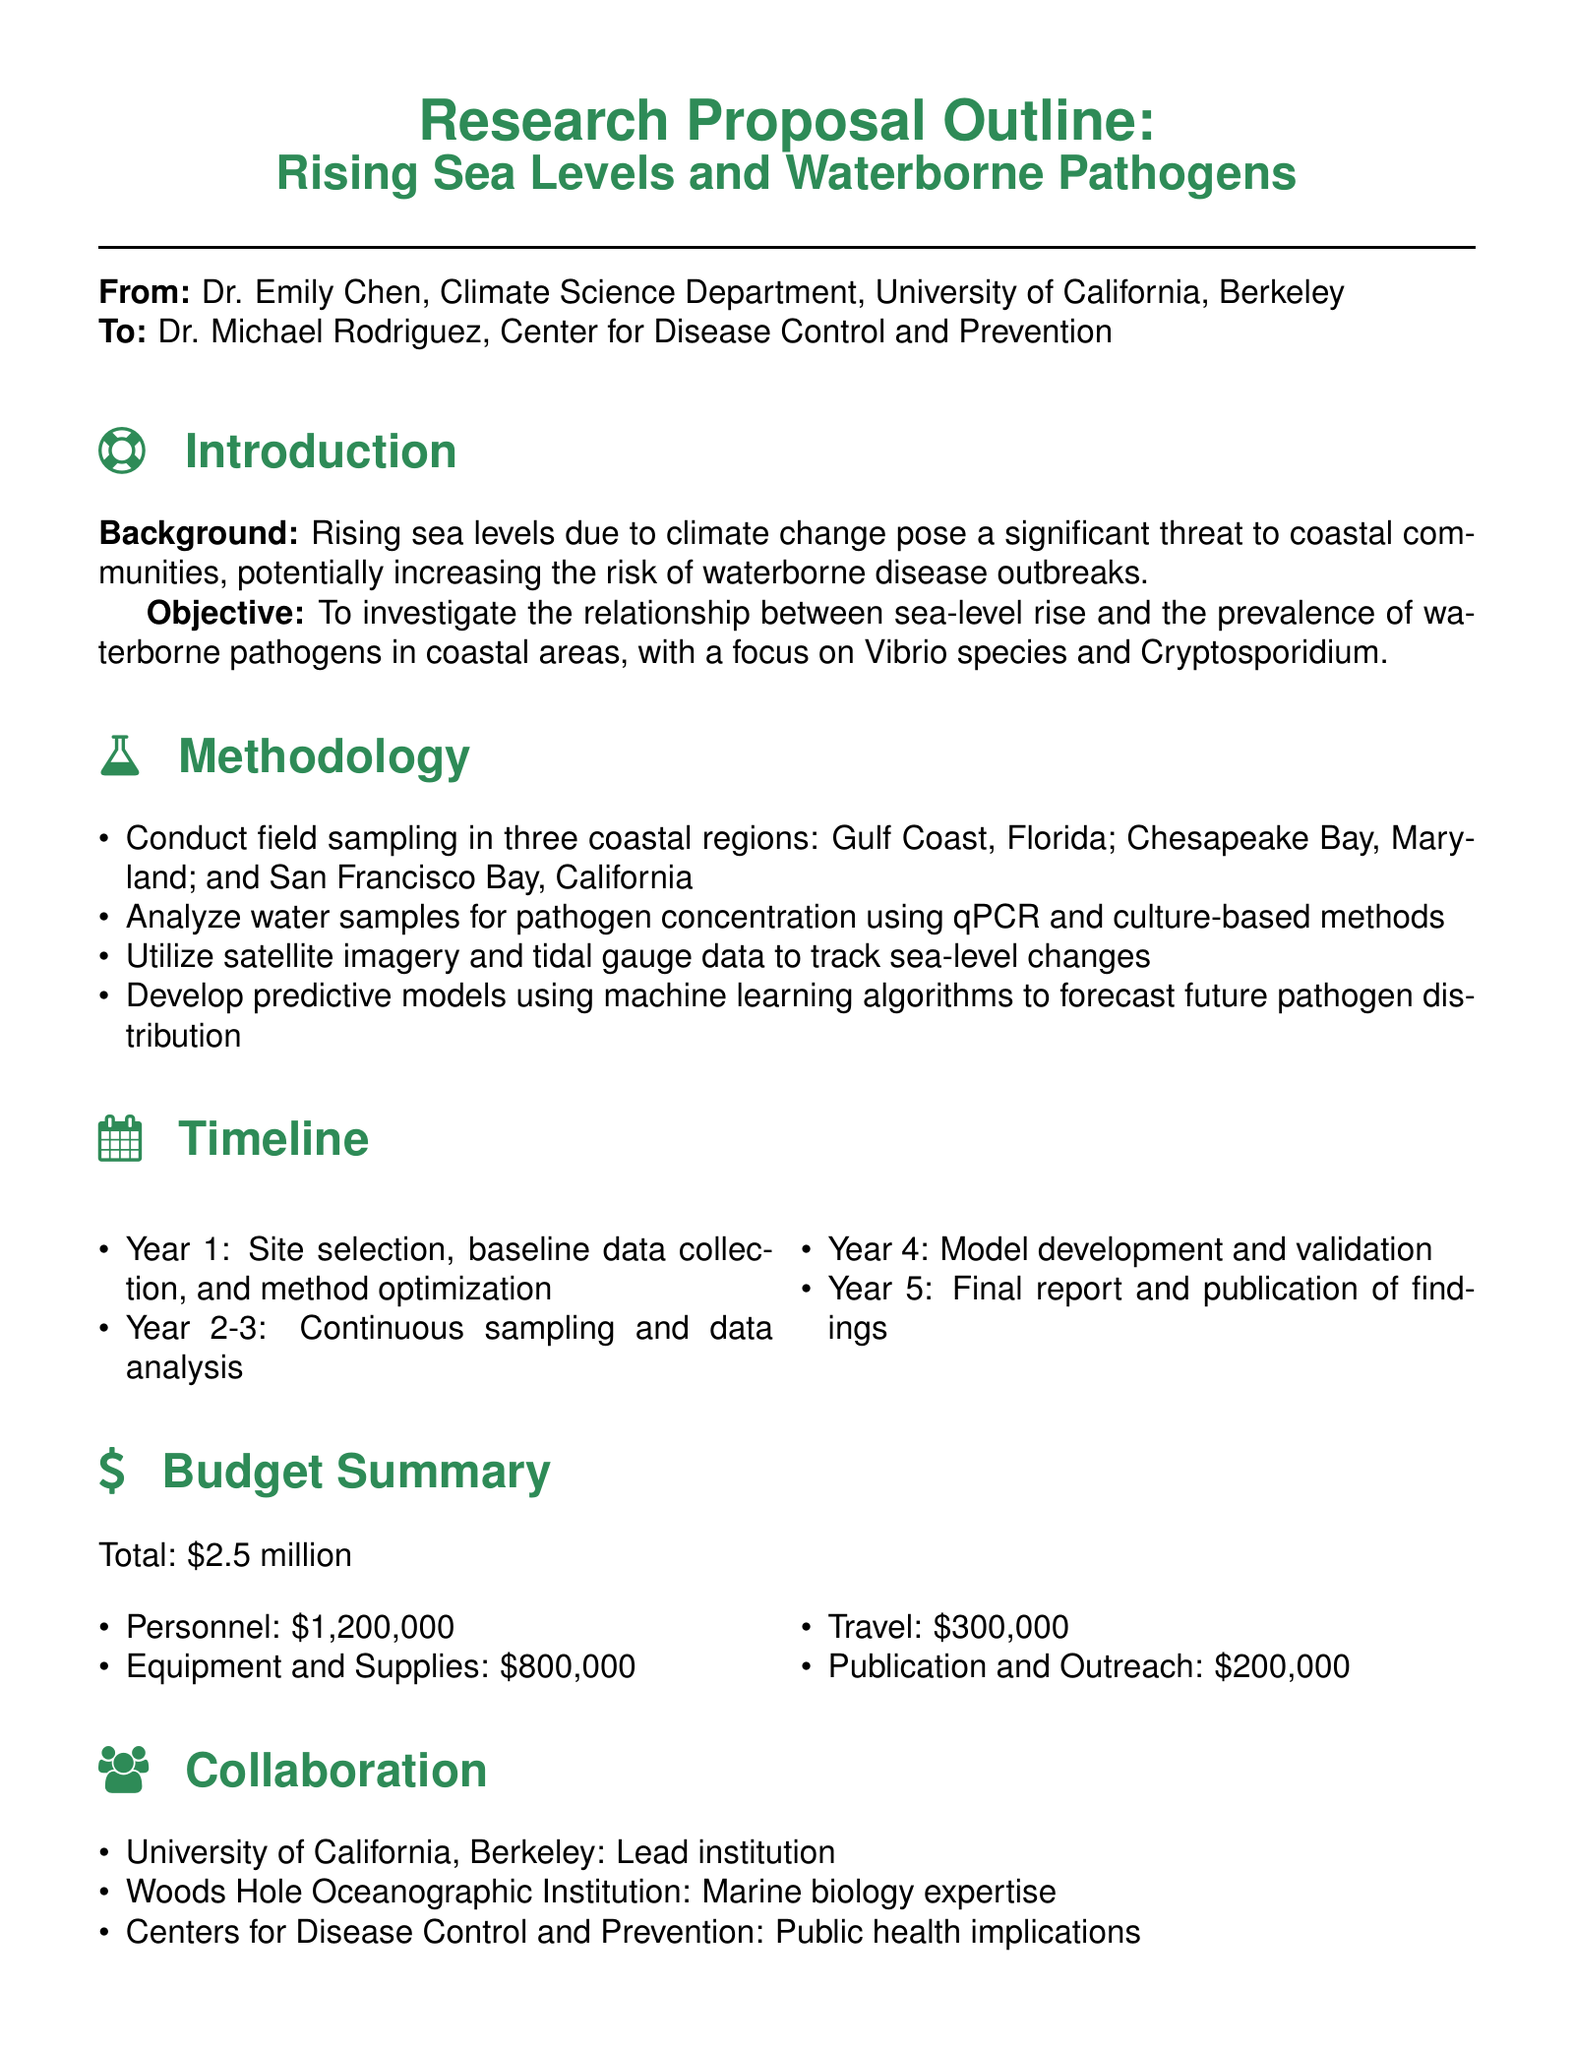what is the total budget for the research proposal? The total budget is specifically listed in the document as $2.5 million.
Answer: $2.5 million who is the lead institution for this research proposal? The document states that the lead institution is the University of California, Berkeley.
Answer: University of California, Berkeley which waterborne pathogens are the focus of the study? The proposal highlights Vibrio species and Cryptosporidium as the pathogens of interest.
Answer: Vibrio species and Cryptosporidium how many years is the research project expected to last? The timeline indicates that the project will last for five years from start to finish.
Answer: Five years what methods will be used to analyze water samples? The document mentions using qPCR and culture-based methods for analyzing water samples.
Answer: qPCR and culture-based methods what is the purpose of the collaboration with the Centers for Disease Control and Prevention? The collaboration with the CDC is focused on addressing public health implications related to the research.
Answer: Public health implications in which regions will field sampling be conducted? The document lists Gulf Coast, Chesapeake Bay, and San Francisco Bay as the sampling locations.
Answer: Gulf Coast, Chesapeake Bay, San Francisco Bay what is one of the expected outcomes of the research? The proposal outlines the development of an early warning system for disease outbreaks as an expected outcome.
Answer: Early warning system for potential disease outbreaks 